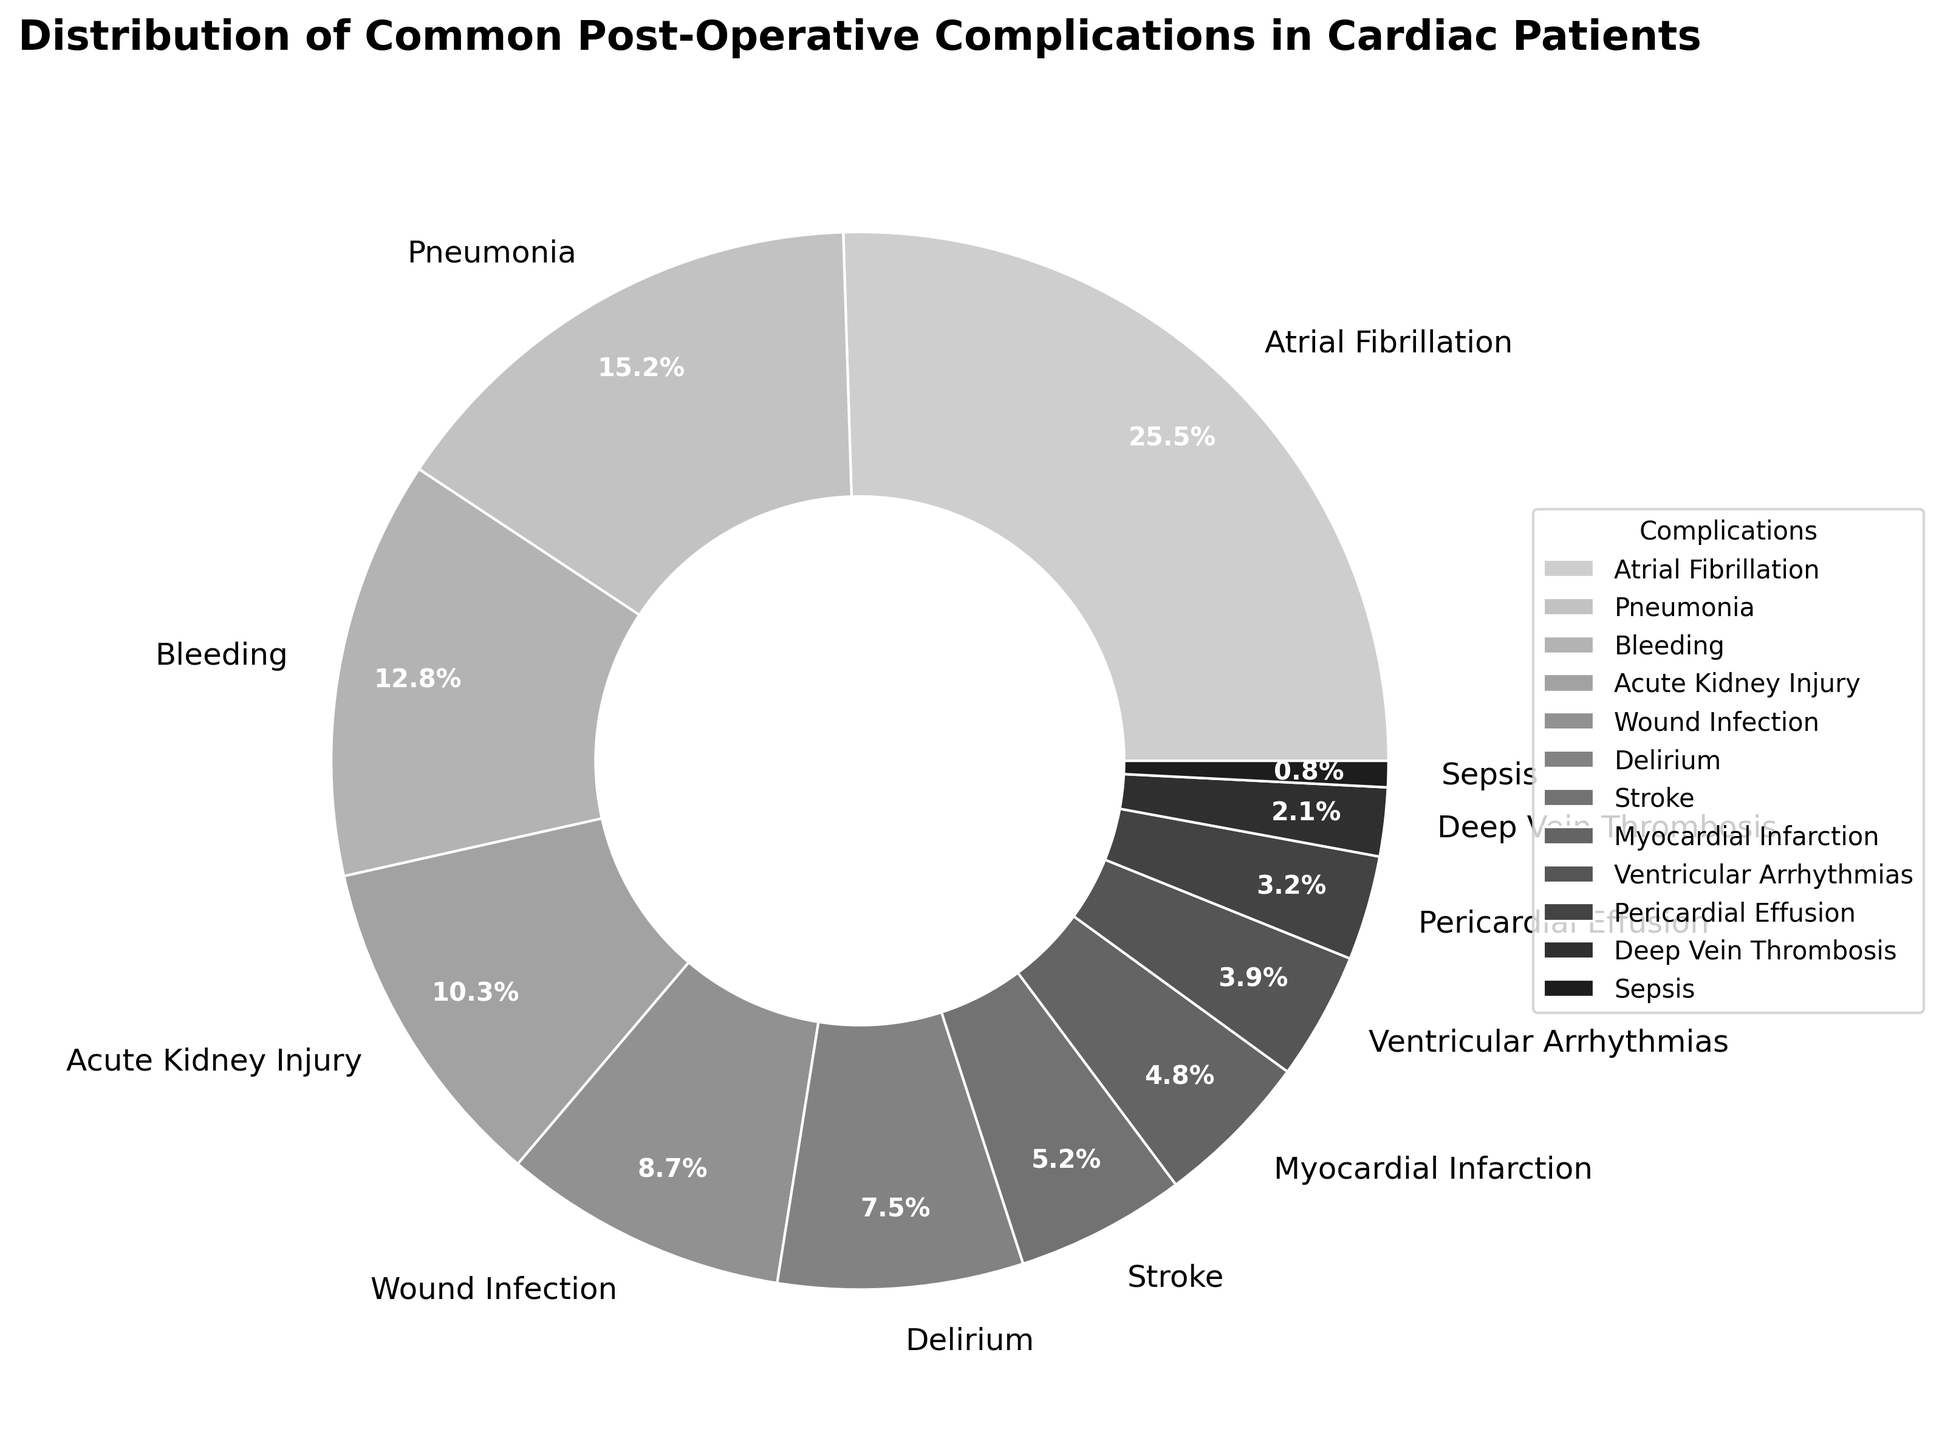Which complication has the highest percentage in the distribution? Atrial Fibrillation has the highest percentage. Refer to the largest wedge in the pie chart and read the label.
Answer: Atrial Fibrillation What is the combined percentage of Bleeding and Acute Kidney Injury? Identify the percentages for Bleeding (12.8%) and Acute Kidney Injury (10.3%). Add them together: 12.8 + 10.3 = 23.1%.
Answer: 23.1% Is the percentage of Stroke higher or lower than that of Delirium? Identify the percentages for Delirium (7.5%) and Stroke (5.2%) from the pie chart. Compare the values: 7.5% is higher than 5.2%.
Answer: Lower How does the percentage of Pneumonia compare to that of Wound Infection? Identify the percentages for Pneumonia (15.2%) and Wound Infection (8.7%). Compare the values: 15.2% is greater than 8.7%.
Answer: Greater What is the difference in percentage between Myocardial Infarction and Ventricular Arrhythmias? Identify the percentages for Myocardial Infarction (4.8%) and Ventricular Arrhythmias (3.9%). Subtract the smaller percentage from the larger: 4.8 - 3.9 = 0.9%.
Answer: 0.9% Which three complications have the lowest percentages? Examine the pie chart and identify the three smallest wedges. Read the labels: Sepsis (0.8%), Deep Vein Thrombosis (2.1%), and Pericardial Effusion (3.2%).
Answer: Sepsis, Deep Vein Thrombosis, Pericardial Effusion What is the average percentage of Wound Infection, Stroke, and Myocardial Infarction? Identify the percentages for Wound Infection (8.7%), Stroke (5.2%), and Myocardial Infarction (4.8%). Add them: 8.7 + 5.2 + 4.8 = 18.7%. Divide by 3: 18.7 / 3 = 6.23%.
Answer: 6.23% By how much does the percentage of Atrial Fibrillation exceed that of Ventricular Arrhythmias? Identify the percentages for Atrial Fibrillation (25.5%) and Ventricular Arrhythmias (3.9%). Subtract the smaller percentage from the larger: 25.5 - 3.9 = 21.6%.
Answer: 21.6% What is the total percentage of complications listed in the pie chart? Sum the percentages of all complications: 25.5 + 15.2 + 12.8 + 10.3 + 8.7 + 7.5 + 5.2 + 4.8 + 3.9 + 3.2 + 2.1 + 0.8 = 100%
Answer: 100% 